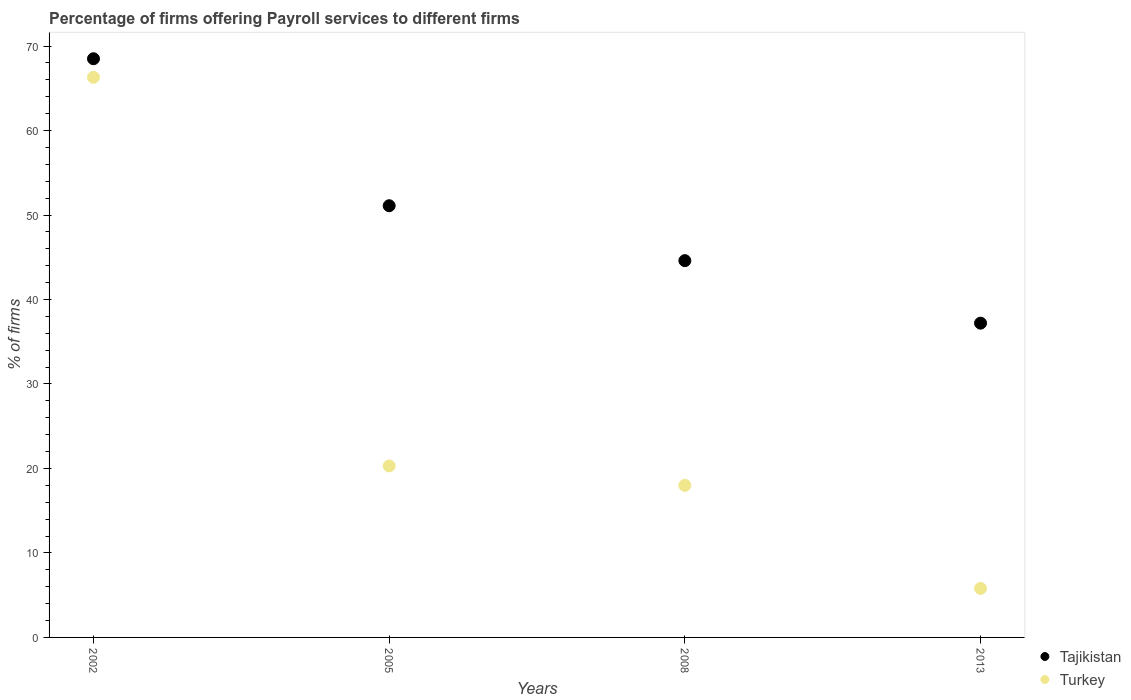How many different coloured dotlines are there?
Provide a short and direct response. 2. What is the percentage of firms offering payroll services in Tajikistan in 2002?
Keep it short and to the point. 68.5. Across all years, what is the maximum percentage of firms offering payroll services in Tajikistan?
Offer a very short reply. 68.5. What is the total percentage of firms offering payroll services in Tajikistan in the graph?
Provide a succinct answer. 201.4. What is the difference between the percentage of firms offering payroll services in Turkey in 2002 and that in 2005?
Your answer should be compact. 46. What is the difference between the percentage of firms offering payroll services in Turkey in 2013 and the percentage of firms offering payroll services in Tajikistan in 2008?
Give a very brief answer. -38.8. What is the average percentage of firms offering payroll services in Tajikistan per year?
Provide a short and direct response. 50.35. In the year 2005, what is the difference between the percentage of firms offering payroll services in Tajikistan and percentage of firms offering payroll services in Turkey?
Your answer should be compact. 30.8. In how many years, is the percentage of firms offering payroll services in Tajikistan greater than 60 %?
Offer a very short reply. 1. What is the ratio of the percentage of firms offering payroll services in Turkey in 2002 to that in 2013?
Keep it short and to the point. 11.43. Is the difference between the percentage of firms offering payroll services in Tajikistan in 2002 and 2013 greater than the difference between the percentage of firms offering payroll services in Turkey in 2002 and 2013?
Provide a succinct answer. No. What is the difference between the highest and the second highest percentage of firms offering payroll services in Tajikistan?
Give a very brief answer. 17.4. What is the difference between the highest and the lowest percentage of firms offering payroll services in Turkey?
Provide a short and direct response. 60.5. In how many years, is the percentage of firms offering payroll services in Turkey greater than the average percentage of firms offering payroll services in Turkey taken over all years?
Offer a terse response. 1. Is the sum of the percentage of firms offering payroll services in Turkey in 2005 and 2013 greater than the maximum percentage of firms offering payroll services in Tajikistan across all years?
Make the answer very short. No. Is the percentage of firms offering payroll services in Turkey strictly greater than the percentage of firms offering payroll services in Tajikistan over the years?
Your response must be concise. No. How many dotlines are there?
Your answer should be very brief. 2. How many years are there in the graph?
Provide a short and direct response. 4. What is the difference between two consecutive major ticks on the Y-axis?
Offer a terse response. 10. Does the graph contain any zero values?
Offer a terse response. No. What is the title of the graph?
Ensure brevity in your answer.  Percentage of firms offering Payroll services to different firms. What is the label or title of the Y-axis?
Ensure brevity in your answer.  % of firms. What is the % of firms in Tajikistan in 2002?
Give a very brief answer. 68.5. What is the % of firms in Turkey in 2002?
Offer a terse response. 66.3. What is the % of firms in Tajikistan in 2005?
Offer a terse response. 51.1. What is the % of firms of Turkey in 2005?
Provide a short and direct response. 20.3. What is the % of firms of Tajikistan in 2008?
Your answer should be very brief. 44.6. What is the % of firms of Turkey in 2008?
Make the answer very short. 18. What is the % of firms of Tajikistan in 2013?
Make the answer very short. 37.2. Across all years, what is the maximum % of firms in Tajikistan?
Offer a very short reply. 68.5. Across all years, what is the maximum % of firms in Turkey?
Provide a short and direct response. 66.3. Across all years, what is the minimum % of firms in Tajikistan?
Provide a succinct answer. 37.2. Across all years, what is the minimum % of firms of Turkey?
Your response must be concise. 5.8. What is the total % of firms of Tajikistan in the graph?
Offer a terse response. 201.4. What is the total % of firms of Turkey in the graph?
Provide a succinct answer. 110.4. What is the difference between the % of firms in Tajikistan in 2002 and that in 2005?
Your answer should be very brief. 17.4. What is the difference between the % of firms of Tajikistan in 2002 and that in 2008?
Your response must be concise. 23.9. What is the difference between the % of firms of Turkey in 2002 and that in 2008?
Your response must be concise. 48.3. What is the difference between the % of firms of Tajikistan in 2002 and that in 2013?
Your answer should be compact. 31.3. What is the difference between the % of firms of Turkey in 2002 and that in 2013?
Your answer should be compact. 60.5. What is the difference between the % of firms in Tajikistan in 2005 and that in 2008?
Provide a succinct answer. 6.5. What is the difference between the % of firms of Turkey in 2005 and that in 2008?
Your answer should be very brief. 2.3. What is the difference between the % of firms of Turkey in 2005 and that in 2013?
Offer a very short reply. 14.5. What is the difference between the % of firms of Tajikistan in 2002 and the % of firms of Turkey in 2005?
Your answer should be compact. 48.2. What is the difference between the % of firms of Tajikistan in 2002 and the % of firms of Turkey in 2008?
Make the answer very short. 50.5. What is the difference between the % of firms in Tajikistan in 2002 and the % of firms in Turkey in 2013?
Offer a very short reply. 62.7. What is the difference between the % of firms of Tajikistan in 2005 and the % of firms of Turkey in 2008?
Provide a succinct answer. 33.1. What is the difference between the % of firms in Tajikistan in 2005 and the % of firms in Turkey in 2013?
Offer a terse response. 45.3. What is the difference between the % of firms in Tajikistan in 2008 and the % of firms in Turkey in 2013?
Provide a short and direct response. 38.8. What is the average % of firms of Tajikistan per year?
Offer a very short reply. 50.35. What is the average % of firms in Turkey per year?
Give a very brief answer. 27.6. In the year 2005, what is the difference between the % of firms in Tajikistan and % of firms in Turkey?
Offer a very short reply. 30.8. In the year 2008, what is the difference between the % of firms of Tajikistan and % of firms of Turkey?
Offer a very short reply. 26.6. In the year 2013, what is the difference between the % of firms in Tajikistan and % of firms in Turkey?
Make the answer very short. 31.4. What is the ratio of the % of firms of Tajikistan in 2002 to that in 2005?
Offer a terse response. 1.34. What is the ratio of the % of firms in Turkey in 2002 to that in 2005?
Your response must be concise. 3.27. What is the ratio of the % of firms of Tajikistan in 2002 to that in 2008?
Make the answer very short. 1.54. What is the ratio of the % of firms in Turkey in 2002 to that in 2008?
Your answer should be compact. 3.68. What is the ratio of the % of firms in Tajikistan in 2002 to that in 2013?
Offer a terse response. 1.84. What is the ratio of the % of firms in Turkey in 2002 to that in 2013?
Your answer should be very brief. 11.43. What is the ratio of the % of firms of Tajikistan in 2005 to that in 2008?
Offer a terse response. 1.15. What is the ratio of the % of firms in Turkey in 2005 to that in 2008?
Your response must be concise. 1.13. What is the ratio of the % of firms in Tajikistan in 2005 to that in 2013?
Offer a very short reply. 1.37. What is the ratio of the % of firms of Turkey in 2005 to that in 2013?
Make the answer very short. 3.5. What is the ratio of the % of firms of Tajikistan in 2008 to that in 2013?
Provide a short and direct response. 1.2. What is the ratio of the % of firms in Turkey in 2008 to that in 2013?
Ensure brevity in your answer.  3.1. What is the difference between the highest and the second highest % of firms in Tajikistan?
Offer a very short reply. 17.4. What is the difference between the highest and the second highest % of firms in Turkey?
Your answer should be compact. 46. What is the difference between the highest and the lowest % of firms of Tajikistan?
Keep it short and to the point. 31.3. What is the difference between the highest and the lowest % of firms in Turkey?
Ensure brevity in your answer.  60.5. 